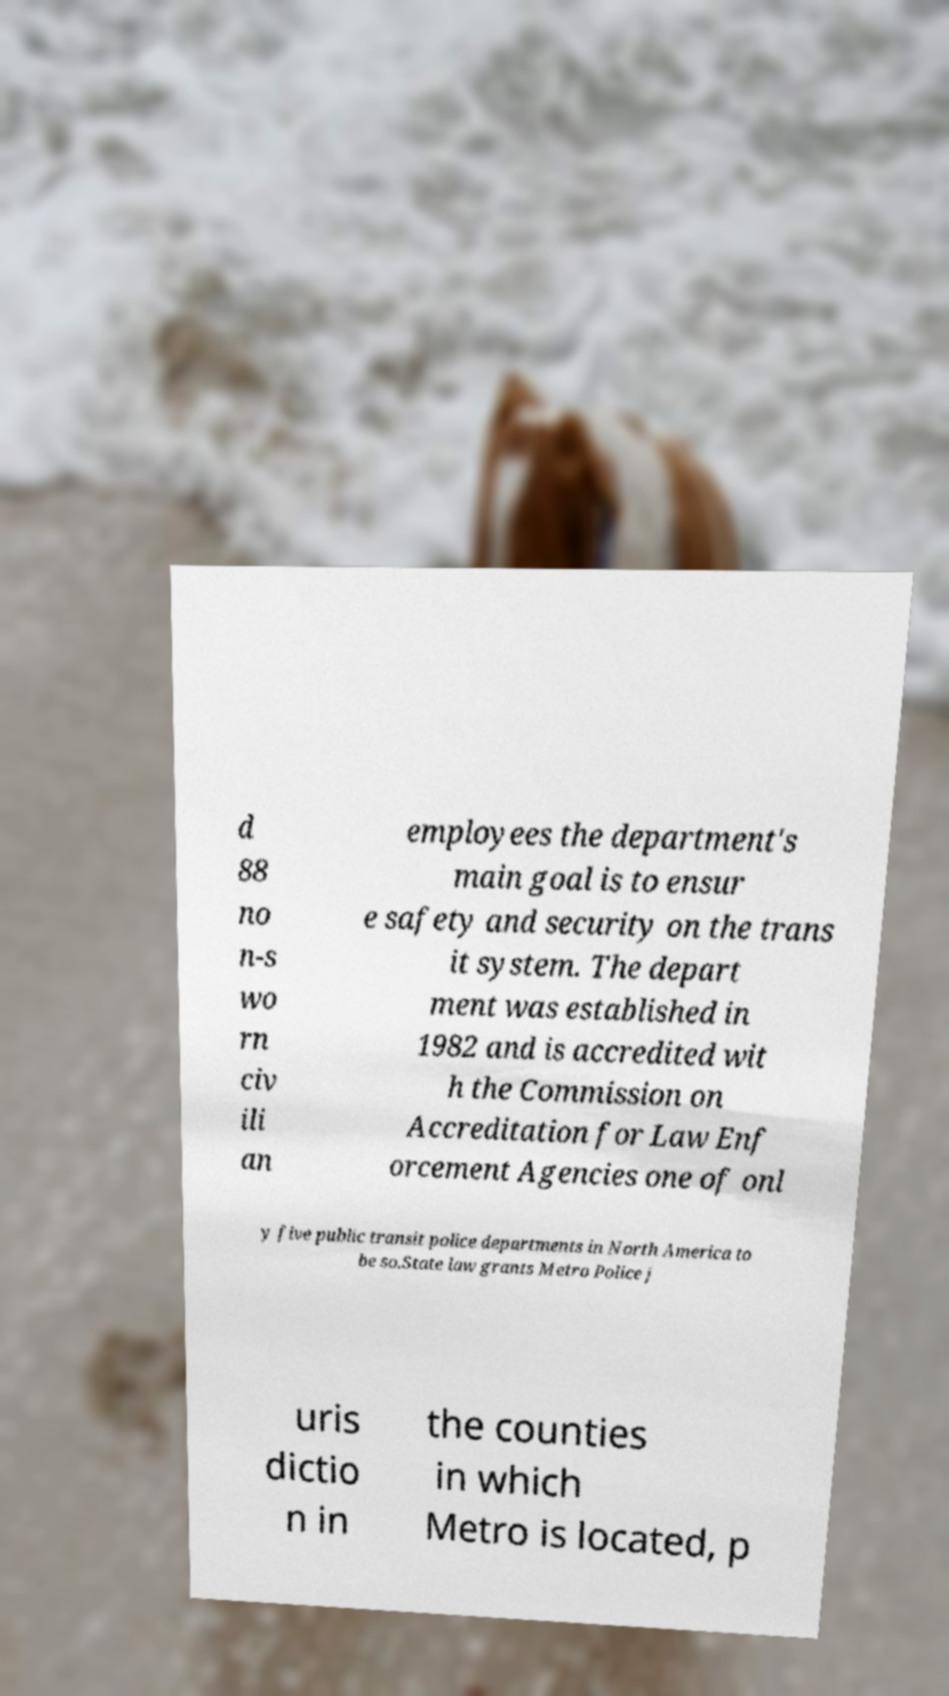I need the written content from this picture converted into text. Can you do that? d 88 no n-s wo rn civ ili an employees the department's main goal is to ensur e safety and security on the trans it system. The depart ment was established in 1982 and is accredited wit h the Commission on Accreditation for Law Enf orcement Agencies one of onl y five public transit police departments in North America to be so.State law grants Metro Police j uris dictio n in the counties in which Metro is located, p 